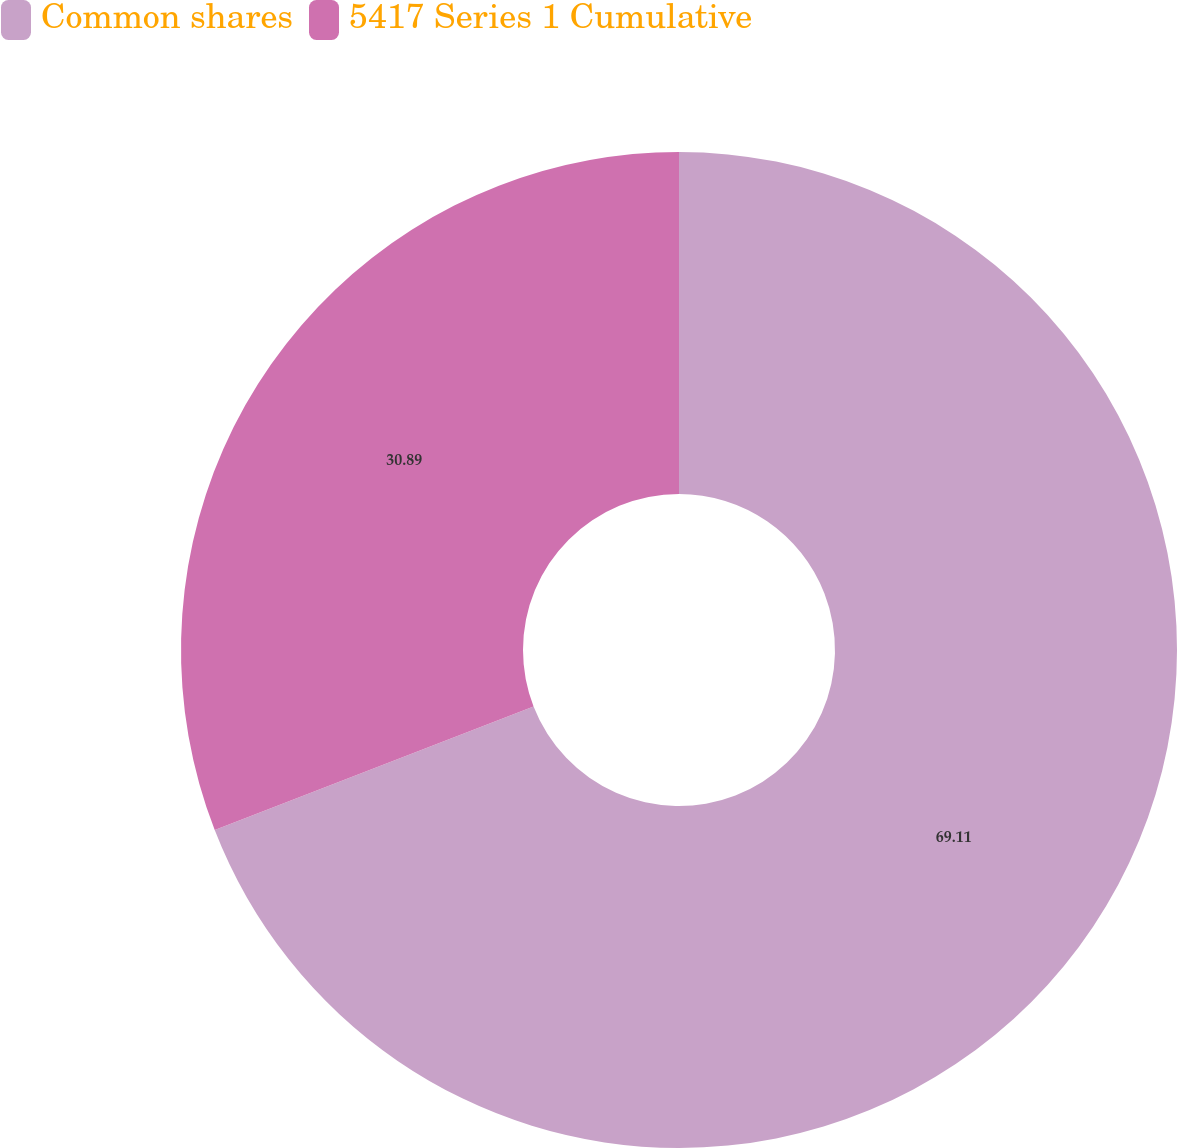<chart> <loc_0><loc_0><loc_500><loc_500><pie_chart><fcel>Common shares<fcel>5417 Series 1 Cumulative<nl><fcel>69.11%<fcel>30.89%<nl></chart> 